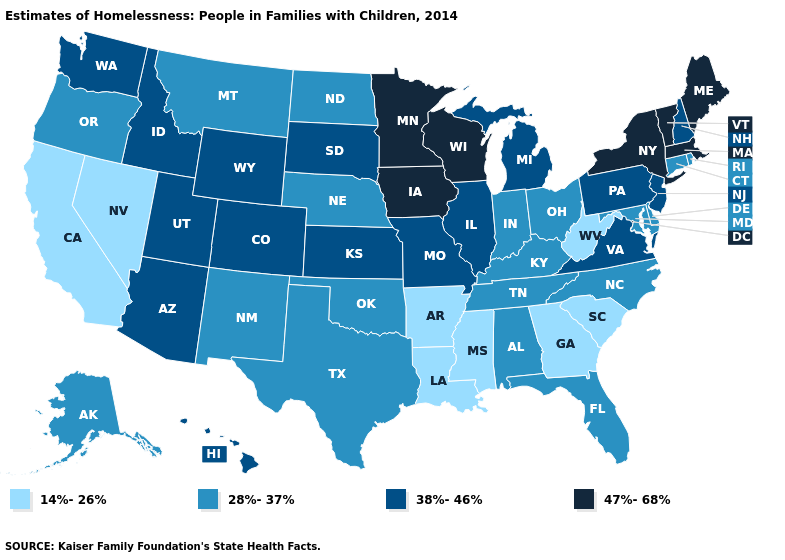Name the states that have a value in the range 38%-46%?
Write a very short answer. Arizona, Colorado, Hawaii, Idaho, Illinois, Kansas, Michigan, Missouri, New Hampshire, New Jersey, Pennsylvania, South Dakota, Utah, Virginia, Washington, Wyoming. Name the states that have a value in the range 47%-68%?
Write a very short answer. Iowa, Maine, Massachusetts, Minnesota, New York, Vermont, Wisconsin. What is the lowest value in the USA?
Quick response, please. 14%-26%. Name the states that have a value in the range 38%-46%?
Concise answer only. Arizona, Colorado, Hawaii, Idaho, Illinois, Kansas, Michigan, Missouri, New Hampshire, New Jersey, Pennsylvania, South Dakota, Utah, Virginia, Washington, Wyoming. Which states have the lowest value in the MidWest?
Answer briefly. Indiana, Nebraska, North Dakota, Ohio. Name the states that have a value in the range 14%-26%?
Keep it brief. Arkansas, California, Georgia, Louisiana, Mississippi, Nevada, South Carolina, West Virginia. What is the value of North Dakota?
Answer briefly. 28%-37%. Which states have the highest value in the USA?
Concise answer only. Iowa, Maine, Massachusetts, Minnesota, New York, Vermont, Wisconsin. Does Minnesota have the highest value in the USA?
Give a very brief answer. Yes. What is the value of Alabama?
Short answer required. 28%-37%. Name the states that have a value in the range 28%-37%?
Keep it brief. Alabama, Alaska, Connecticut, Delaware, Florida, Indiana, Kentucky, Maryland, Montana, Nebraska, New Mexico, North Carolina, North Dakota, Ohio, Oklahoma, Oregon, Rhode Island, Tennessee, Texas. What is the highest value in states that border Illinois?
Keep it brief. 47%-68%. What is the value of Connecticut?
Short answer required. 28%-37%. How many symbols are there in the legend?
Quick response, please. 4. What is the highest value in the USA?
Keep it brief. 47%-68%. 